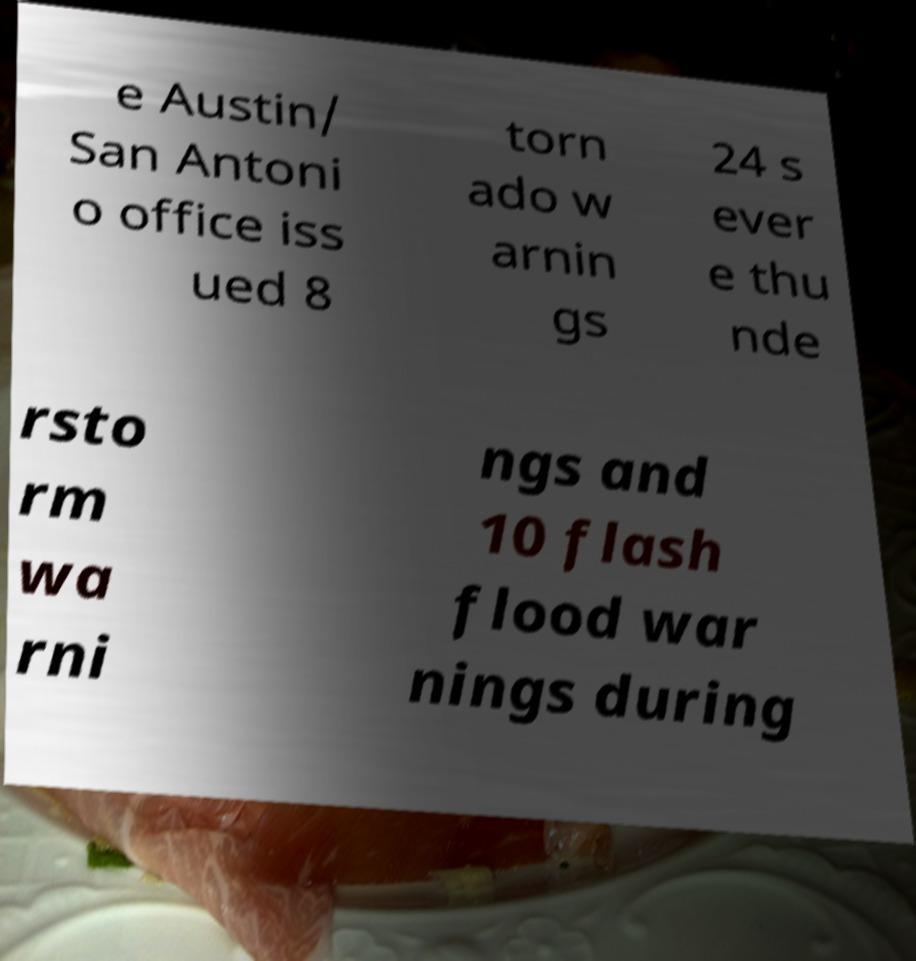What messages or text are displayed in this image? I need them in a readable, typed format. e Austin/ San Antoni o office iss ued 8 torn ado w arnin gs 24 s ever e thu nde rsto rm wa rni ngs and 10 flash flood war nings during 